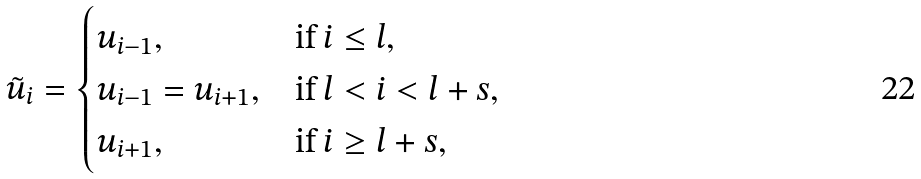<formula> <loc_0><loc_0><loc_500><loc_500>\tilde { u } _ { i } = \begin{cases} u _ { i - 1 } , & \text {if $i\leq l$} , \\ u _ { i - 1 } = u _ { i + 1 } , & \text {if $l<i<l+s$} , \\ u _ { i + 1 } , & \text {if $i\geq l+s$} , \end{cases}</formula> 